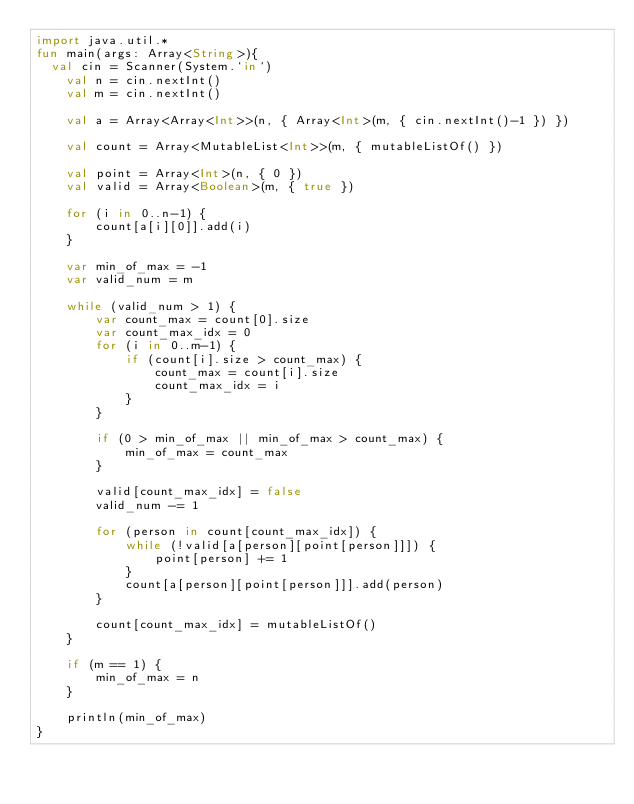<code> <loc_0><loc_0><loc_500><loc_500><_Kotlin_>import java.util.*
fun main(args: Array<String>){
	val cin = Scanner(System.`in`)
    val n = cin.nextInt()
    val m = cin.nextInt()

    val a = Array<Array<Int>>(n, { Array<Int>(m, { cin.nextInt()-1 }) })

    val count = Array<MutableList<Int>>(m, { mutableListOf() })

    val point = Array<Int>(n, { 0 })
    val valid = Array<Boolean>(m, { true })

    for (i in 0..n-1) {
        count[a[i][0]].add(i)
    }

    var min_of_max = -1
    var valid_num = m

    while (valid_num > 1) {
        var count_max = count[0].size
        var count_max_idx = 0
        for (i in 0..m-1) {
            if (count[i].size > count_max) {
                count_max = count[i].size
                count_max_idx = i
            }
        }

        if (0 > min_of_max || min_of_max > count_max) {
            min_of_max = count_max
        }

        valid[count_max_idx] = false
        valid_num -= 1

        for (person in count[count_max_idx]) {
            while (!valid[a[person][point[person]]]) {
                point[person] += 1
            }
            count[a[person][point[person]]].add(person)
        }

        count[count_max_idx] = mutableListOf()
    }

    if (m == 1) {
        min_of_max = n
    }
    
    println(min_of_max)
}</code> 